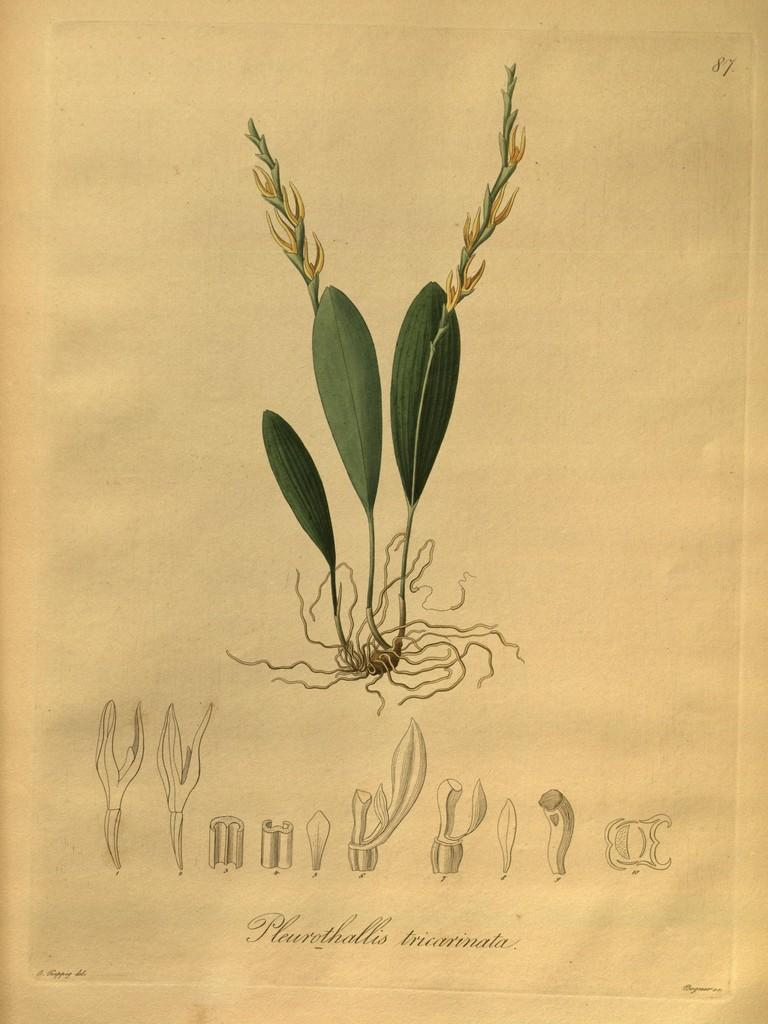What is the main subject of the paper in the image? The paper contains drawings of leaves, roots, and plants. Is there any text on the paper? Yes, there is text at the bottom of the paper. What type of underwear is visible in the image? There is no underwear present in the image. What is the reason for the drawings of leaves, roots, and plants on the paper? The facts provided do not give any information about the reason for the drawings, so we cannot answer this question. 